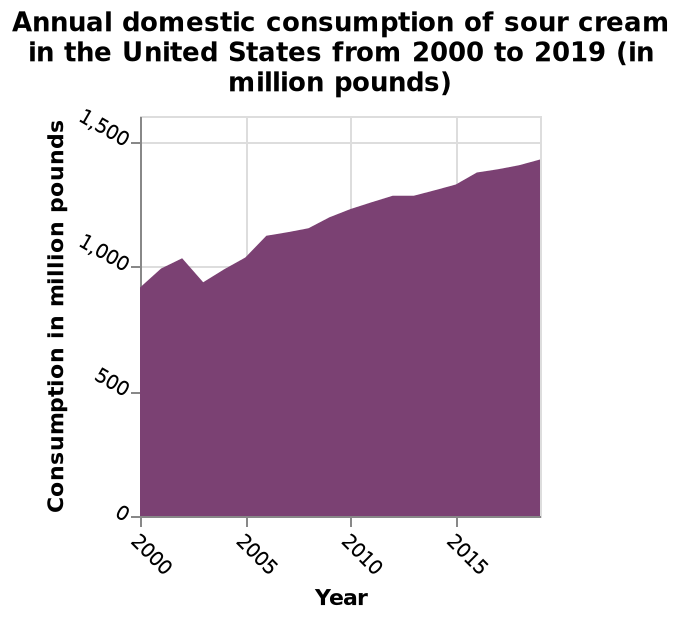<image>
How has the consumption of sour cream changed over time?  The consumption of sour cream has generally increased over the years, with a dip between 2000 and 2005. In what unit is the consumption of sour cream measured?  The consumption of sour cream is measured in million pounds. 